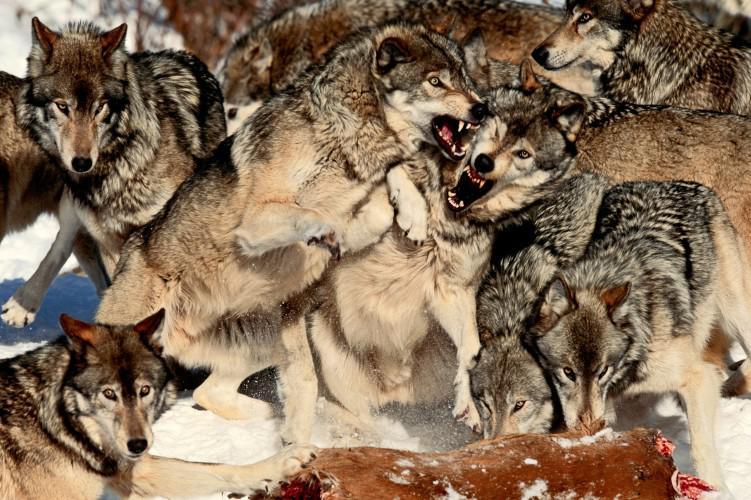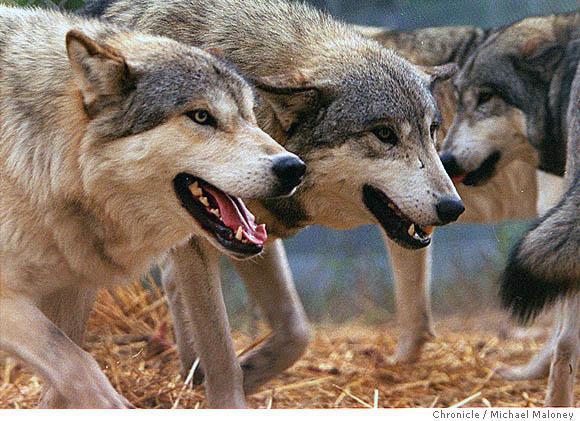The first image is the image on the left, the second image is the image on the right. Evaluate the accuracy of this statement regarding the images: "All of the wolves are out in the snow.". Is it true? Answer yes or no. No. The first image is the image on the left, the second image is the image on the right. Assess this claim about the two images: "There's no more than two wolves in the right image.". Correct or not? Answer yes or no. No. 